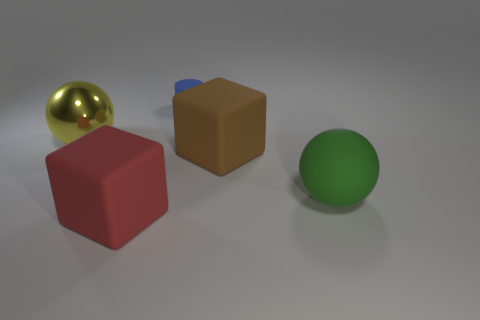There is a object behind the metallic sphere; are there any large yellow metallic balls that are behind it?
Offer a terse response. No. What color is the big ball that is the same material as the tiny blue thing?
Offer a very short reply. Green. Is the number of cubes greater than the number of purple rubber cylinders?
Ensure brevity in your answer.  Yes. What number of objects are either big balls that are in front of the yellow ball or big yellow things?
Your answer should be very brief. 2. Is there another shiny object of the same size as the shiny object?
Make the answer very short. No. Is the number of objects less than the number of big red cubes?
Provide a short and direct response. No. What number of spheres are big matte things or small blue objects?
Make the answer very short. 1. What number of large rubber spheres are the same color as the small matte cylinder?
Make the answer very short. 0. How big is the matte thing that is in front of the brown thing and right of the red matte object?
Offer a very short reply. Large. Is the number of blue objects that are on the right side of the big rubber ball less than the number of red rubber things?
Your answer should be compact. Yes. 